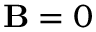<formula> <loc_0><loc_0><loc_500><loc_500>B = 0</formula> 